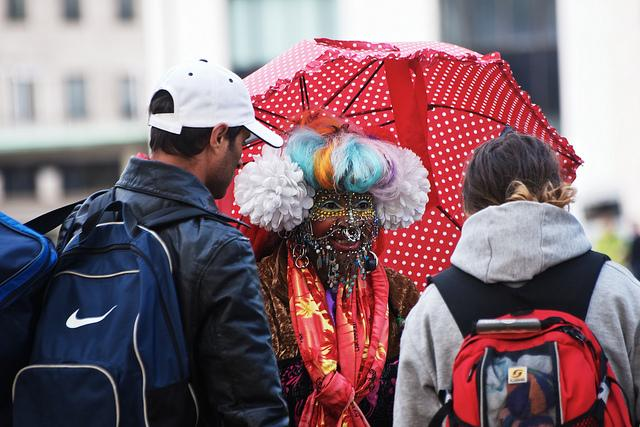What does the woman have all over her face? piercings 